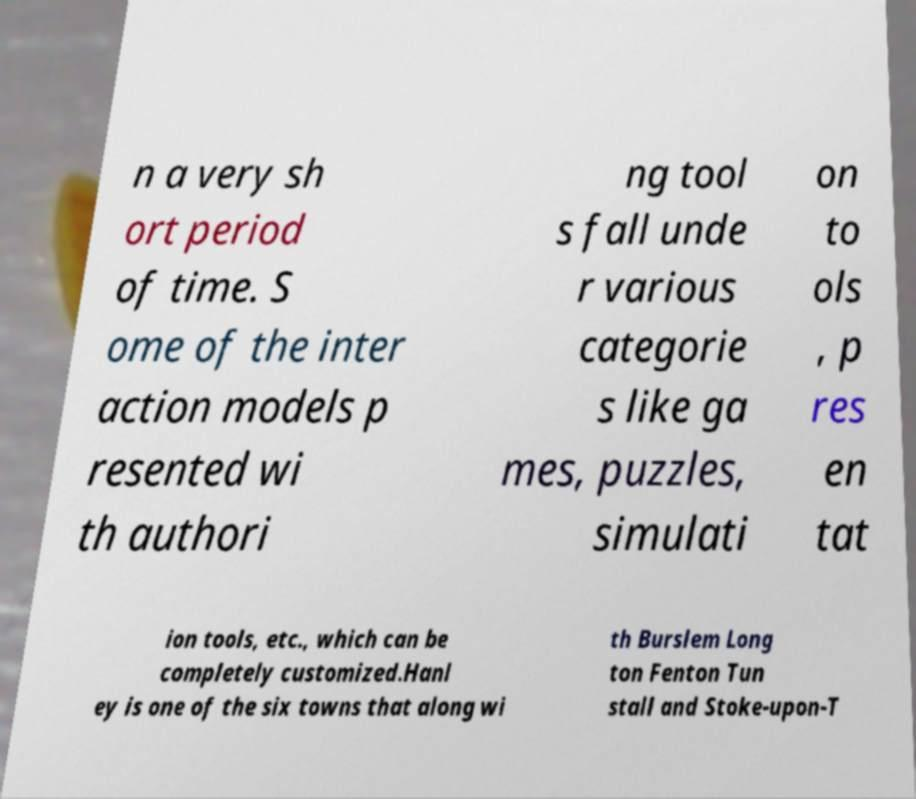Can you read and provide the text displayed in the image?This photo seems to have some interesting text. Can you extract and type it out for me? n a very sh ort period of time. S ome of the inter action models p resented wi th authori ng tool s fall unde r various categorie s like ga mes, puzzles, simulati on to ols , p res en tat ion tools, etc., which can be completely customized.Hanl ey is one of the six towns that along wi th Burslem Long ton Fenton Tun stall and Stoke-upon-T 